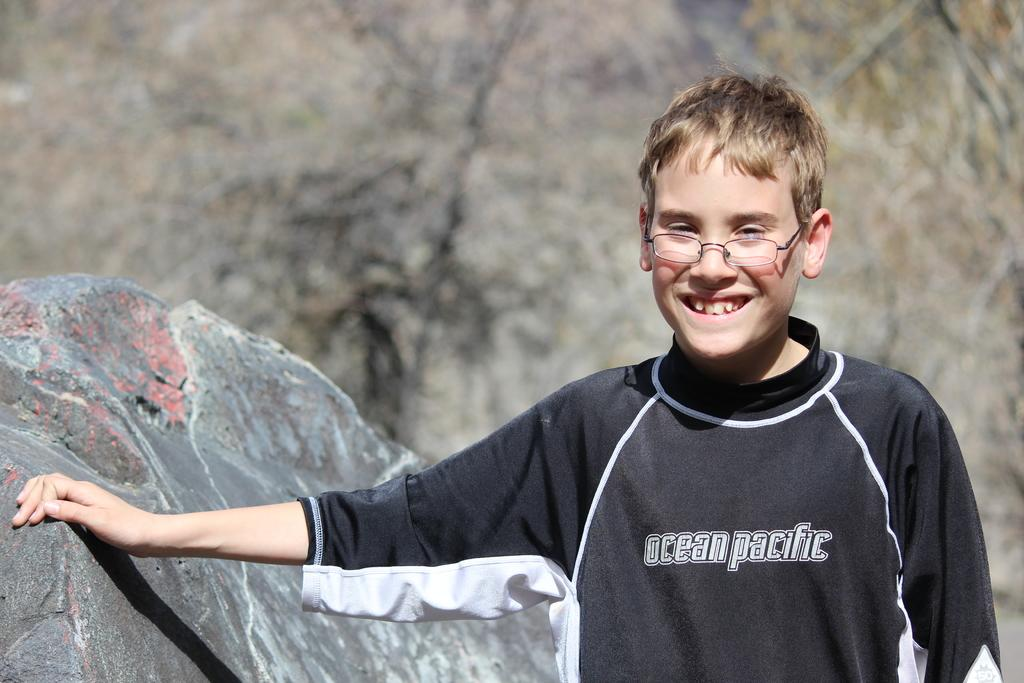Provide a one-sentence caption for the provided image. A young boy stands outside wearing glasses and a dark Ocean Pacific shirt. 